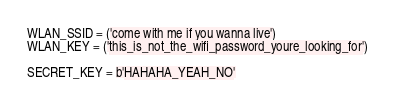<code> <loc_0><loc_0><loc_500><loc_500><_Python_>
WLAN_SSID = ('come with me if you wanna live')
WLAN_KEY = ('this_is_not_the_wifi_password_youre_looking_for')

SECRET_KEY = b'HAHAHA_YEAH_NO'
</code> 